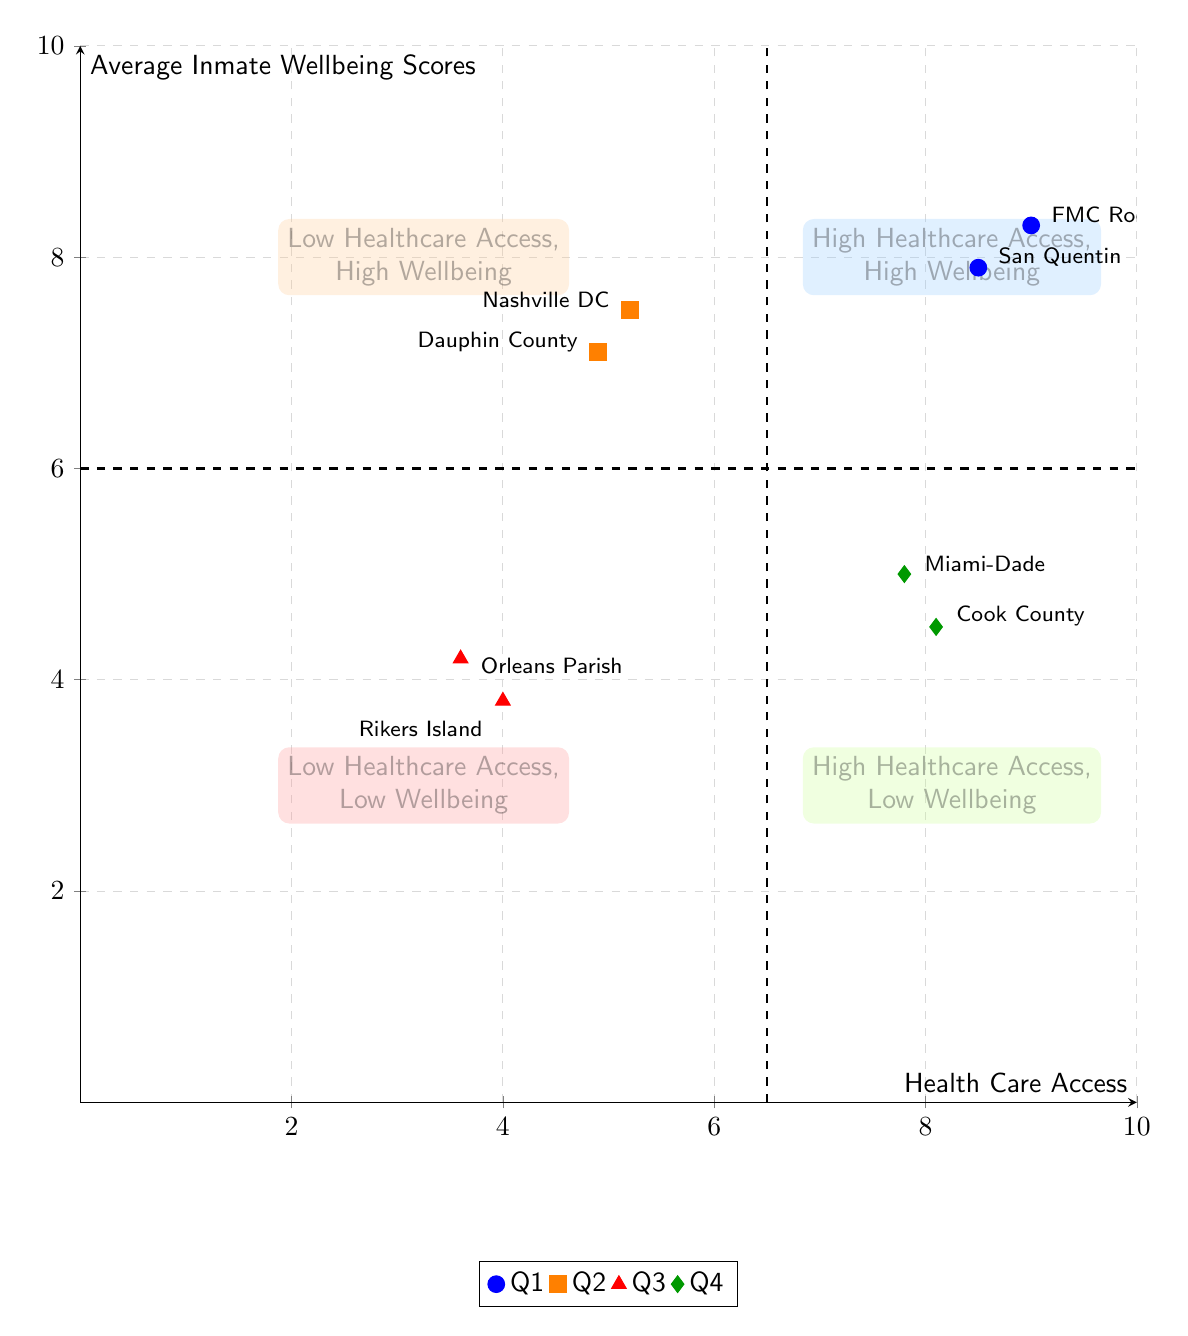What are the health care access scores of San Quentin State Prison? The diagram indicates that San Quentin State Prison has a health care access score of 8.5, as noted within the High Healthcare Access, High Wellbeing quadrant.
Answer: 8.5 Which facility has the lowest average inmate wellbeing score? According to the diagram, Rikers Island has the lowest average inmate wellbeing score of 3.8, located in the Low Healthcare Access, Low Wellbeing quadrant.
Answer: 3.8 How many facilities are in the High Healthcare Access, Low Wellbeing quadrant? The diagram displays two facilities in the High Healthcare Access, Low Wellbeing quadrant: Cook County Jail and Miami-Dade Corrections & Rehabilitation.
Answer: 2 What is the relationship between health care access and wellbeing for Rikers Island? Rikers Island, located in the Low Healthcare Access, Low Wellbeing quadrant, has both low healthcare access (4.0) and low wellbeing (3.8), indicating that limited healthcare access correlates to poor wellbeing outcomes.
Answer: Negative correlation Which prison is in the Low Healthcare Access, High Wellbeing quadrant? The diagram shows two facilities in the Low Healthcare Access, High Wellbeing quadrant: Nashville Detention Center and Dauphin County Prison, both depicted with higher wellbeing scores despite low healthcare access.
Answer: Nashville Detention Center and Dauphin County Prison What is the wellbeing score for Miami-Dade Corrections & Rehabilitation? Miami-Dade Corrections & Rehabilitation has a wellbeing score of 5.0, found within the High Healthcare Access, Low Wellbeing quadrant in the diagram.
Answer: 5.0 How does healthcare access impact inmate wellbeing in the diagram's quadrants? The diagram uses quadrants to demonstrate that high healthcare access usually corresponds with higher wellbeing scores, while low healthcare access leads to lower wellbeing scores, reflecting a direct impact on inmate health outcomes.
Answer: Direct impact Which quadrant contains only one facility with high healthcare access? The diagram indicates that the Low Healthcare Access, High Wellbeing quadrant contains only Nashville Detention Center as one of its facilities.
Answer: Low Healthcare Access, High Wellbeing quadrant 